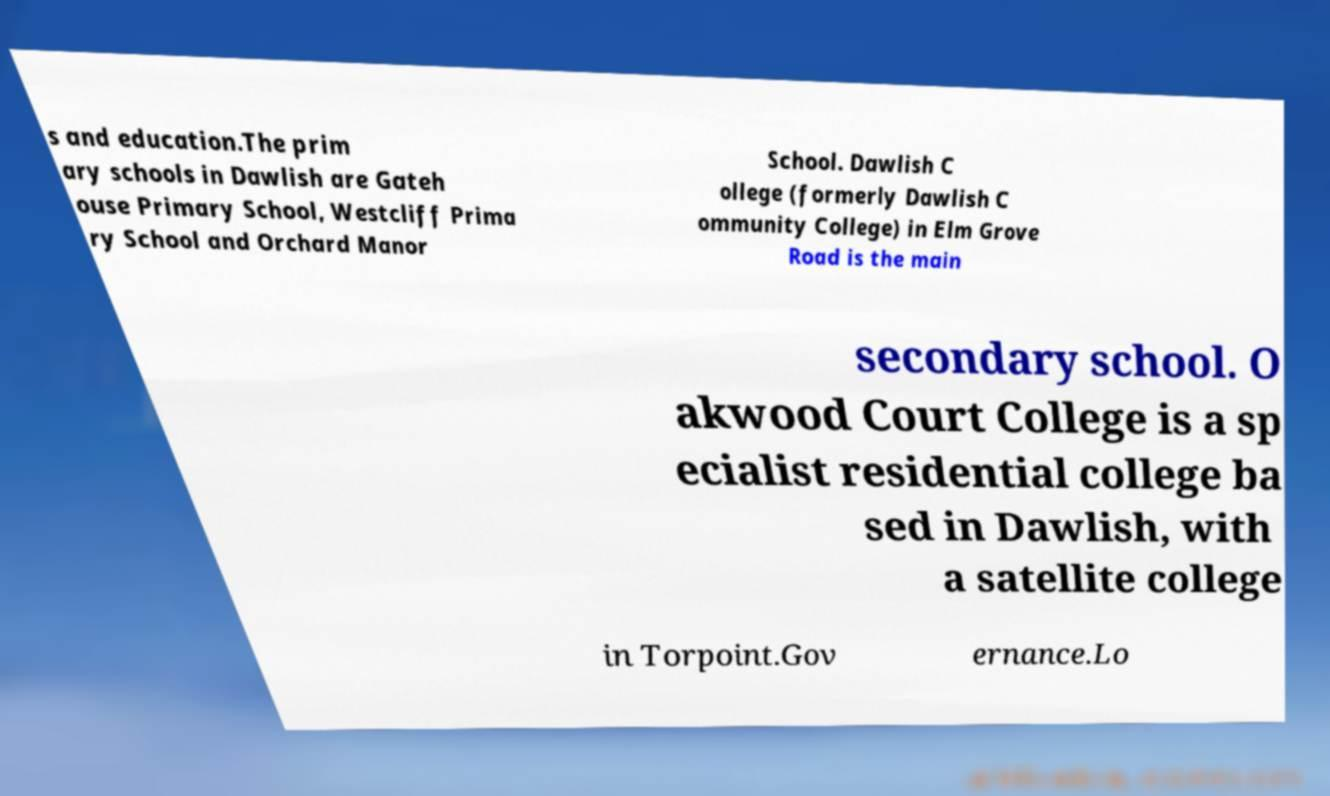For documentation purposes, I need the text within this image transcribed. Could you provide that? s and education.The prim ary schools in Dawlish are Gateh ouse Primary School, Westcliff Prima ry School and Orchard Manor School. Dawlish C ollege (formerly Dawlish C ommunity College) in Elm Grove Road is the main secondary school. O akwood Court College is a sp ecialist residential college ba sed in Dawlish, with a satellite college in Torpoint.Gov ernance.Lo 